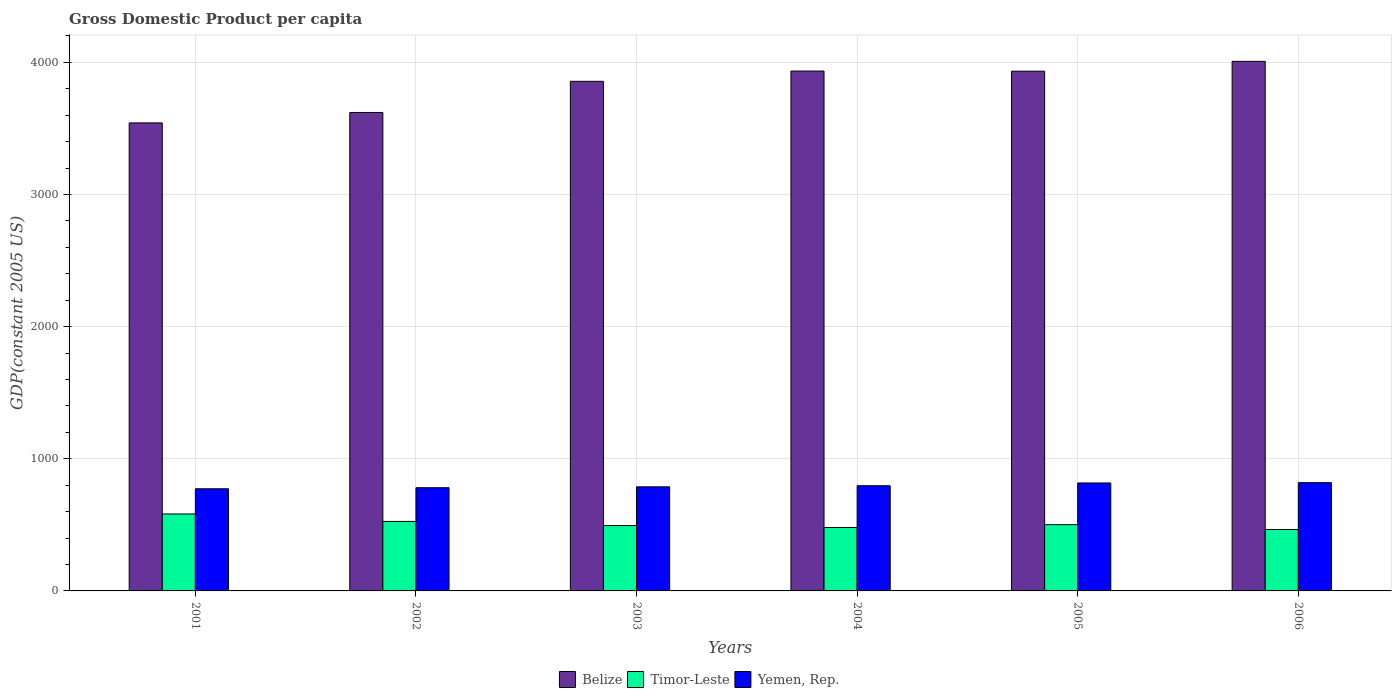Are the number of bars per tick equal to the number of legend labels?
Offer a terse response. Yes. How many bars are there on the 4th tick from the right?
Offer a terse response. 3. In how many cases, is the number of bars for a given year not equal to the number of legend labels?
Your response must be concise. 0. What is the GDP per capita in Timor-Leste in 2002?
Ensure brevity in your answer.  526.06. Across all years, what is the maximum GDP per capita in Belize?
Ensure brevity in your answer.  4007.73. Across all years, what is the minimum GDP per capita in Timor-Leste?
Offer a very short reply. 464.78. What is the total GDP per capita in Belize in the graph?
Your response must be concise. 2.29e+04. What is the difference between the GDP per capita in Yemen, Rep. in 2002 and that in 2004?
Ensure brevity in your answer.  -14.98. What is the difference between the GDP per capita in Timor-Leste in 2003 and the GDP per capita in Belize in 2001?
Your answer should be very brief. -3047.2. What is the average GDP per capita in Yemen, Rep. per year?
Give a very brief answer. 795.73. In the year 2004, what is the difference between the GDP per capita in Timor-Leste and GDP per capita in Yemen, Rep.?
Your answer should be compact. -315.95. In how many years, is the GDP per capita in Yemen, Rep. greater than 4000 US$?
Your answer should be compact. 0. What is the ratio of the GDP per capita in Belize in 2003 to that in 2006?
Keep it short and to the point. 0.96. What is the difference between the highest and the second highest GDP per capita in Belize?
Your response must be concise. 73.43. What is the difference between the highest and the lowest GDP per capita in Timor-Leste?
Your answer should be compact. 117.6. Is the sum of the GDP per capita in Timor-Leste in 2005 and 2006 greater than the maximum GDP per capita in Belize across all years?
Provide a short and direct response. No. What does the 1st bar from the left in 2004 represents?
Your response must be concise. Belize. What does the 3rd bar from the right in 2005 represents?
Your answer should be compact. Belize. Is it the case that in every year, the sum of the GDP per capita in Belize and GDP per capita in Yemen, Rep. is greater than the GDP per capita in Timor-Leste?
Provide a succinct answer. Yes. Are all the bars in the graph horizontal?
Your response must be concise. No. Does the graph contain any zero values?
Make the answer very short. No. Does the graph contain grids?
Your answer should be compact. Yes. Where does the legend appear in the graph?
Give a very brief answer. Bottom center. What is the title of the graph?
Provide a short and direct response. Gross Domestic Product per capita. Does "Panama" appear as one of the legend labels in the graph?
Keep it short and to the point. No. What is the label or title of the X-axis?
Your response must be concise. Years. What is the label or title of the Y-axis?
Keep it short and to the point. GDP(constant 2005 US). What is the GDP(constant 2005 US) in Belize in 2001?
Your response must be concise. 3541.94. What is the GDP(constant 2005 US) in Timor-Leste in 2001?
Offer a very short reply. 582.38. What is the GDP(constant 2005 US) of Yemen, Rep. in 2001?
Your answer should be compact. 773.08. What is the GDP(constant 2005 US) in Belize in 2002?
Provide a short and direct response. 3620.81. What is the GDP(constant 2005 US) in Timor-Leste in 2002?
Your answer should be very brief. 526.06. What is the GDP(constant 2005 US) of Yemen, Rep. in 2002?
Ensure brevity in your answer.  781.07. What is the GDP(constant 2005 US) in Belize in 2003?
Your response must be concise. 3856.68. What is the GDP(constant 2005 US) in Timor-Leste in 2003?
Your response must be concise. 494.74. What is the GDP(constant 2005 US) of Yemen, Rep. in 2003?
Your answer should be very brief. 787.67. What is the GDP(constant 2005 US) in Belize in 2004?
Make the answer very short. 3934.3. What is the GDP(constant 2005 US) of Timor-Leste in 2004?
Your answer should be compact. 480.1. What is the GDP(constant 2005 US) in Yemen, Rep. in 2004?
Offer a very short reply. 796.05. What is the GDP(constant 2005 US) of Belize in 2005?
Provide a succinct answer. 3933.23. What is the GDP(constant 2005 US) in Timor-Leste in 2005?
Provide a short and direct response. 501.43. What is the GDP(constant 2005 US) in Yemen, Rep. in 2005?
Keep it short and to the point. 817.08. What is the GDP(constant 2005 US) in Belize in 2006?
Ensure brevity in your answer.  4007.73. What is the GDP(constant 2005 US) in Timor-Leste in 2006?
Provide a succinct answer. 464.78. What is the GDP(constant 2005 US) of Yemen, Rep. in 2006?
Your answer should be compact. 819.43. Across all years, what is the maximum GDP(constant 2005 US) in Belize?
Make the answer very short. 4007.73. Across all years, what is the maximum GDP(constant 2005 US) in Timor-Leste?
Keep it short and to the point. 582.38. Across all years, what is the maximum GDP(constant 2005 US) of Yemen, Rep.?
Offer a very short reply. 819.43. Across all years, what is the minimum GDP(constant 2005 US) of Belize?
Your response must be concise. 3541.94. Across all years, what is the minimum GDP(constant 2005 US) of Timor-Leste?
Your answer should be compact. 464.78. Across all years, what is the minimum GDP(constant 2005 US) of Yemen, Rep.?
Provide a short and direct response. 773.08. What is the total GDP(constant 2005 US) of Belize in the graph?
Your answer should be compact. 2.29e+04. What is the total GDP(constant 2005 US) in Timor-Leste in the graph?
Offer a very short reply. 3049.48. What is the total GDP(constant 2005 US) of Yemen, Rep. in the graph?
Make the answer very short. 4774.37. What is the difference between the GDP(constant 2005 US) of Belize in 2001 and that in 2002?
Make the answer very short. -78.87. What is the difference between the GDP(constant 2005 US) in Timor-Leste in 2001 and that in 2002?
Make the answer very short. 56.32. What is the difference between the GDP(constant 2005 US) of Yemen, Rep. in 2001 and that in 2002?
Provide a short and direct response. -7.99. What is the difference between the GDP(constant 2005 US) of Belize in 2001 and that in 2003?
Ensure brevity in your answer.  -314.74. What is the difference between the GDP(constant 2005 US) in Timor-Leste in 2001 and that in 2003?
Offer a terse response. 87.64. What is the difference between the GDP(constant 2005 US) of Yemen, Rep. in 2001 and that in 2003?
Keep it short and to the point. -14.59. What is the difference between the GDP(constant 2005 US) in Belize in 2001 and that in 2004?
Make the answer very short. -392.36. What is the difference between the GDP(constant 2005 US) of Timor-Leste in 2001 and that in 2004?
Ensure brevity in your answer.  102.27. What is the difference between the GDP(constant 2005 US) of Yemen, Rep. in 2001 and that in 2004?
Your response must be concise. -22.97. What is the difference between the GDP(constant 2005 US) in Belize in 2001 and that in 2005?
Keep it short and to the point. -391.29. What is the difference between the GDP(constant 2005 US) of Timor-Leste in 2001 and that in 2005?
Your response must be concise. 80.95. What is the difference between the GDP(constant 2005 US) of Yemen, Rep. in 2001 and that in 2005?
Ensure brevity in your answer.  -44. What is the difference between the GDP(constant 2005 US) of Belize in 2001 and that in 2006?
Your response must be concise. -465.79. What is the difference between the GDP(constant 2005 US) in Timor-Leste in 2001 and that in 2006?
Make the answer very short. 117.6. What is the difference between the GDP(constant 2005 US) in Yemen, Rep. in 2001 and that in 2006?
Offer a very short reply. -46.35. What is the difference between the GDP(constant 2005 US) of Belize in 2002 and that in 2003?
Your answer should be very brief. -235.86. What is the difference between the GDP(constant 2005 US) of Timor-Leste in 2002 and that in 2003?
Provide a succinct answer. 31.32. What is the difference between the GDP(constant 2005 US) of Yemen, Rep. in 2002 and that in 2003?
Your answer should be very brief. -6.6. What is the difference between the GDP(constant 2005 US) in Belize in 2002 and that in 2004?
Provide a succinct answer. -313.48. What is the difference between the GDP(constant 2005 US) in Timor-Leste in 2002 and that in 2004?
Keep it short and to the point. 45.96. What is the difference between the GDP(constant 2005 US) in Yemen, Rep. in 2002 and that in 2004?
Provide a short and direct response. -14.98. What is the difference between the GDP(constant 2005 US) of Belize in 2002 and that in 2005?
Your answer should be very brief. -312.42. What is the difference between the GDP(constant 2005 US) of Timor-Leste in 2002 and that in 2005?
Offer a terse response. 24.63. What is the difference between the GDP(constant 2005 US) in Yemen, Rep. in 2002 and that in 2005?
Offer a very short reply. -36.02. What is the difference between the GDP(constant 2005 US) of Belize in 2002 and that in 2006?
Offer a terse response. -386.91. What is the difference between the GDP(constant 2005 US) in Timor-Leste in 2002 and that in 2006?
Offer a terse response. 61.28. What is the difference between the GDP(constant 2005 US) in Yemen, Rep. in 2002 and that in 2006?
Keep it short and to the point. -38.36. What is the difference between the GDP(constant 2005 US) in Belize in 2003 and that in 2004?
Offer a very short reply. -77.62. What is the difference between the GDP(constant 2005 US) of Timor-Leste in 2003 and that in 2004?
Your response must be concise. 14.64. What is the difference between the GDP(constant 2005 US) of Yemen, Rep. in 2003 and that in 2004?
Provide a succinct answer. -8.38. What is the difference between the GDP(constant 2005 US) in Belize in 2003 and that in 2005?
Provide a succinct answer. -76.56. What is the difference between the GDP(constant 2005 US) in Timor-Leste in 2003 and that in 2005?
Keep it short and to the point. -6.69. What is the difference between the GDP(constant 2005 US) in Yemen, Rep. in 2003 and that in 2005?
Keep it short and to the point. -29.41. What is the difference between the GDP(constant 2005 US) in Belize in 2003 and that in 2006?
Offer a terse response. -151.05. What is the difference between the GDP(constant 2005 US) in Timor-Leste in 2003 and that in 2006?
Provide a short and direct response. 29.96. What is the difference between the GDP(constant 2005 US) in Yemen, Rep. in 2003 and that in 2006?
Provide a succinct answer. -31.76. What is the difference between the GDP(constant 2005 US) in Belize in 2004 and that in 2005?
Provide a succinct answer. 1.06. What is the difference between the GDP(constant 2005 US) in Timor-Leste in 2004 and that in 2005?
Ensure brevity in your answer.  -21.33. What is the difference between the GDP(constant 2005 US) of Yemen, Rep. in 2004 and that in 2005?
Provide a succinct answer. -21.03. What is the difference between the GDP(constant 2005 US) of Belize in 2004 and that in 2006?
Offer a very short reply. -73.43. What is the difference between the GDP(constant 2005 US) in Timor-Leste in 2004 and that in 2006?
Your response must be concise. 15.33. What is the difference between the GDP(constant 2005 US) of Yemen, Rep. in 2004 and that in 2006?
Ensure brevity in your answer.  -23.38. What is the difference between the GDP(constant 2005 US) in Belize in 2005 and that in 2006?
Ensure brevity in your answer.  -74.49. What is the difference between the GDP(constant 2005 US) in Timor-Leste in 2005 and that in 2006?
Provide a short and direct response. 36.65. What is the difference between the GDP(constant 2005 US) in Yemen, Rep. in 2005 and that in 2006?
Offer a terse response. -2.34. What is the difference between the GDP(constant 2005 US) in Belize in 2001 and the GDP(constant 2005 US) in Timor-Leste in 2002?
Ensure brevity in your answer.  3015.88. What is the difference between the GDP(constant 2005 US) in Belize in 2001 and the GDP(constant 2005 US) in Yemen, Rep. in 2002?
Provide a short and direct response. 2760.88. What is the difference between the GDP(constant 2005 US) of Timor-Leste in 2001 and the GDP(constant 2005 US) of Yemen, Rep. in 2002?
Offer a terse response. -198.69. What is the difference between the GDP(constant 2005 US) in Belize in 2001 and the GDP(constant 2005 US) in Timor-Leste in 2003?
Keep it short and to the point. 3047.2. What is the difference between the GDP(constant 2005 US) in Belize in 2001 and the GDP(constant 2005 US) in Yemen, Rep. in 2003?
Offer a terse response. 2754.27. What is the difference between the GDP(constant 2005 US) of Timor-Leste in 2001 and the GDP(constant 2005 US) of Yemen, Rep. in 2003?
Offer a very short reply. -205.29. What is the difference between the GDP(constant 2005 US) of Belize in 2001 and the GDP(constant 2005 US) of Timor-Leste in 2004?
Offer a very short reply. 3061.84. What is the difference between the GDP(constant 2005 US) of Belize in 2001 and the GDP(constant 2005 US) of Yemen, Rep. in 2004?
Your answer should be compact. 2745.89. What is the difference between the GDP(constant 2005 US) in Timor-Leste in 2001 and the GDP(constant 2005 US) in Yemen, Rep. in 2004?
Your answer should be very brief. -213.67. What is the difference between the GDP(constant 2005 US) of Belize in 2001 and the GDP(constant 2005 US) of Timor-Leste in 2005?
Offer a terse response. 3040.51. What is the difference between the GDP(constant 2005 US) in Belize in 2001 and the GDP(constant 2005 US) in Yemen, Rep. in 2005?
Keep it short and to the point. 2724.86. What is the difference between the GDP(constant 2005 US) in Timor-Leste in 2001 and the GDP(constant 2005 US) in Yemen, Rep. in 2005?
Offer a terse response. -234.71. What is the difference between the GDP(constant 2005 US) in Belize in 2001 and the GDP(constant 2005 US) in Timor-Leste in 2006?
Make the answer very short. 3077.16. What is the difference between the GDP(constant 2005 US) of Belize in 2001 and the GDP(constant 2005 US) of Yemen, Rep. in 2006?
Offer a terse response. 2722.52. What is the difference between the GDP(constant 2005 US) in Timor-Leste in 2001 and the GDP(constant 2005 US) in Yemen, Rep. in 2006?
Your response must be concise. -237.05. What is the difference between the GDP(constant 2005 US) of Belize in 2002 and the GDP(constant 2005 US) of Timor-Leste in 2003?
Your answer should be very brief. 3126.08. What is the difference between the GDP(constant 2005 US) in Belize in 2002 and the GDP(constant 2005 US) in Yemen, Rep. in 2003?
Offer a very short reply. 2833.15. What is the difference between the GDP(constant 2005 US) of Timor-Leste in 2002 and the GDP(constant 2005 US) of Yemen, Rep. in 2003?
Provide a short and direct response. -261.61. What is the difference between the GDP(constant 2005 US) of Belize in 2002 and the GDP(constant 2005 US) of Timor-Leste in 2004?
Provide a succinct answer. 3140.71. What is the difference between the GDP(constant 2005 US) in Belize in 2002 and the GDP(constant 2005 US) in Yemen, Rep. in 2004?
Your answer should be very brief. 2824.76. What is the difference between the GDP(constant 2005 US) in Timor-Leste in 2002 and the GDP(constant 2005 US) in Yemen, Rep. in 2004?
Ensure brevity in your answer.  -269.99. What is the difference between the GDP(constant 2005 US) in Belize in 2002 and the GDP(constant 2005 US) in Timor-Leste in 2005?
Offer a very short reply. 3119.39. What is the difference between the GDP(constant 2005 US) of Belize in 2002 and the GDP(constant 2005 US) of Yemen, Rep. in 2005?
Offer a very short reply. 2803.73. What is the difference between the GDP(constant 2005 US) in Timor-Leste in 2002 and the GDP(constant 2005 US) in Yemen, Rep. in 2005?
Keep it short and to the point. -291.02. What is the difference between the GDP(constant 2005 US) in Belize in 2002 and the GDP(constant 2005 US) in Timor-Leste in 2006?
Your answer should be very brief. 3156.04. What is the difference between the GDP(constant 2005 US) of Belize in 2002 and the GDP(constant 2005 US) of Yemen, Rep. in 2006?
Your response must be concise. 2801.39. What is the difference between the GDP(constant 2005 US) of Timor-Leste in 2002 and the GDP(constant 2005 US) of Yemen, Rep. in 2006?
Provide a succinct answer. -293.37. What is the difference between the GDP(constant 2005 US) of Belize in 2003 and the GDP(constant 2005 US) of Timor-Leste in 2004?
Your response must be concise. 3376.57. What is the difference between the GDP(constant 2005 US) in Belize in 2003 and the GDP(constant 2005 US) in Yemen, Rep. in 2004?
Your answer should be very brief. 3060.63. What is the difference between the GDP(constant 2005 US) of Timor-Leste in 2003 and the GDP(constant 2005 US) of Yemen, Rep. in 2004?
Provide a short and direct response. -301.31. What is the difference between the GDP(constant 2005 US) of Belize in 2003 and the GDP(constant 2005 US) of Timor-Leste in 2005?
Your answer should be compact. 3355.25. What is the difference between the GDP(constant 2005 US) in Belize in 2003 and the GDP(constant 2005 US) in Yemen, Rep. in 2005?
Your answer should be compact. 3039.59. What is the difference between the GDP(constant 2005 US) in Timor-Leste in 2003 and the GDP(constant 2005 US) in Yemen, Rep. in 2005?
Your answer should be very brief. -322.34. What is the difference between the GDP(constant 2005 US) in Belize in 2003 and the GDP(constant 2005 US) in Timor-Leste in 2006?
Your response must be concise. 3391.9. What is the difference between the GDP(constant 2005 US) in Belize in 2003 and the GDP(constant 2005 US) in Yemen, Rep. in 2006?
Offer a terse response. 3037.25. What is the difference between the GDP(constant 2005 US) of Timor-Leste in 2003 and the GDP(constant 2005 US) of Yemen, Rep. in 2006?
Offer a terse response. -324.69. What is the difference between the GDP(constant 2005 US) in Belize in 2004 and the GDP(constant 2005 US) in Timor-Leste in 2005?
Keep it short and to the point. 3432.87. What is the difference between the GDP(constant 2005 US) in Belize in 2004 and the GDP(constant 2005 US) in Yemen, Rep. in 2005?
Your answer should be very brief. 3117.21. What is the difference between the GDP(constant 2005 US) in Timor-Leste in 2004 and the GDP(constant 2005 US) in Yemen, Rep. in 2005?
Your answer should be very brief. -336.98. What is the difference between the GDP(constant 2005 US) of Belize in 2004 and the GDP(constant 2005 US) of Timor-Leste in 2006?
Ensure brevity in your answer.  3469.52. What is the difference between the GDP(constant 2005 US) in Belize in 2004 and the GDP(constant 2005 US) in Yemen, Rep. in 2006?
Your answer should be very brief. 3114.87. What is the difference between the GDP(constant 2005 US) of Timor-Leste in 2004 and the GDP(constant 2005 US) of Yemen, Rep. in 2006?
Make the answer very short. -339.32. What is the difference between the GDP(constant 2005 US) of Belize in 2005 and the GDP(constant 2005 US) of Timor-Leste in 2006?
Provide a short and direct response. 3468.46. What is the difference between the GDP(constant 2005 US) of Belize in 2005 and the GDP(constant 2005 US) of Yemen, Rep. in 2006?
Ensure brevity in your answer.  3113.81. What is the difference between the GDP(constant 2005 US) in Timor-Leste in 2005 and the GDP(constant 2005 US) in Yemen, Rep. in 2006?
Provide a succinct answer. -318. What is the average GDP(constant 2005 US) of Belize per year?
Provide a short and direct response. 3815.78. What is the average GDP(constant 2005 US) of Timor-Leste per year?
Your response must be concise. 508.25. What is the average GDP(constant 2005 US) in Yemen, Rep. per year?
Ensure brevity in your answer.  795.73. In the year 2001, what is the difference between the GDP(constant 2005 US) of Belize and GDP(constant 2005 US) of Timor-Leste?
Offer a very short reply. 2959.57. In the year 2001, what is the difference between the GDP(constant 2005 US) in Belize and GDP(constant 2005 US) in Yemen, Rep.?
Your answer should be very brief. 2768.86. In the year 2001, what is the difference between the GDP(constant 2005 US) of Timor-Leste and GDP(constant 2005 US) of Yemen, Rep.?
Offer a very short reply. -190.7. In the year 2002, what is the difference between the GDP(constant 2005 US) in Belize and GDP(constant 2005 US) in Timor-Leste?
Offer a terse response. 3094.76. In the year 2002, what is the difference between the GDP(constant 2005 US) of Belize and GDP(constant 2005 US) of Yemen, Rep.?
Provide a succinct answer. 2839.75. In the year 2002, what is the difference between the GDP(constant 2005 US) in Timor-Leste and GDP(constant 2005 US) in Yemen, Rep.?
Your answer should be very brief. -255.01. In the year 2003, what is the difference between the GDP(constant 2005 US) in Belize and GDP(constant 2005 US) in Timor-Leste?
Give a very brief answer. 3361.94. In the year 2003, what is the difference between the GDP(constant 2005 US) of Belize and GDP(constant 2005 US) of Yemen, Rep.?
Your answer should be compact. 3069.01. In the year 2003, what is the difference between the GDP(constant 2005 US) in Timor-Leste and GDP(constant 2005 US) in Yemen, Rep.?
Ensure brevity in your answer.  -292.93. In the year 2004, what is the difference between the GDP(constant 2005 US) of Belize and GDP(constant 2005 US) of Timor-Leste?
Your response must be concise. 3454.19. In the year 2004, what is the difference between the GDP(constant 2005 US) of Belize and GDP(constant 2005 US) of Yemen, Rep.?
Ensure brevity in your answer.  3138.25. In the year 2004, what is the difference between the GDP(constant 2005 US) of Timor-Leste and GDP(constant 2005 US) of Yemen, Rep.?
Your response must be concise. -315.95. In the year 2005, what is the difference between the GDP(constant 2005 US) of Belize and GDP(constant 2005 US) of Timor-Leste?
Make the answer very short. 3431.81. In the year 2005, what is the difference between the GDP(constant 2005 US) in Belize and GDP(constant 2005 US) in Yemen, Rep.?
Offer a terse response. 3116.15. In the year 2005, what is the difference between the GDP(constant 2005 US) of Timor-Leste and GDP(constant 2005 US) of Yemen, Rep.?
Your response must be concise. -315.65. In the year 2006, what is the difference between the GDP(constant 2005 US) of Belize and GDP(constant 2005 US) of Timor-Leste?
Make the answer very short. 3542.95. In the year 2006, what is the difference between the GDP(constant 2005 US) of Belize and GDP(constant 2005 US) of Yemen, Rep.?
Your answer should be very brief. 3188.3. In the year 2006, what is the difference between the GDP(constant 2005 US) in Timor-Leste and GDP(constant 2005 US) in Yemen, Rep.?
Provide a succinct answer. -354.65. What is the ratio of the GDP(constant 2005 US) of Belize in 2001 to that in 2002?
Keep it short and to the point. 0.98. What is the ratio of the GDP(constant 2005 US) in Timor-Leste in 2001 to that in 2002?
Your answer should be very brief. 1.11. What is the ratio of the GDP(constant 2005 US) in Yemen, Rep. in 2001 to that in 2002?
Give a very brief answer. 0.99. What is the ratio of the GDP(constant 2005 US) in Belize in 2001 to that in 2003?
Ensure brevity in your answer.  0.92. What is the ratio of the GDP(constant 2005 US) of Timor-Leste in 2001 to that in 2003?
Your answer should be very brief. 1.18. What is the ratio of the GDP(constant 2005 US) in Yemen, Rep. in 2001 to that in 2003?
Provide a short and direct response. 0.98. What is the ratio of the GDP(constant 2005 US) in Belize in 2001 to that in 2004?
Give a very brief answer. 0.9. What is the ratio of the GDP(constant 2005 US) of Timor-Leste in 2001 to that in 2004?
Offer a terse response. 1.21. What is the ratio of the GDP(constant 2005 US) of Yemen, Rep. in 2001 to that in 2004?
Your answer should be very brief. 0.97. What is the ratio of the GDP(constant 2005 US) in Belize in 2001 to that in 2005?
Provide a short and direct response. 0.9. What is the ratio of the GDP(constant 2005 US) in Timor-Leste in 2001 to that in 2005?
Your response must be concise. 1.16. What is the ratio of the GDP(constant 2005 US) in Yemen, Rep. in 2001 to that in 2005?
Keep it short and to the point. 0.95. What is the ratio of the GDP(constant 2005 US) of Belize in 2001 to that in 2006?
Offer a terse response. 0.88. What is the ratio of the GDP(constant 2005 US) of Timor-Leste in 2001 to that in 2006?
Your answer should be very brief. 1.25. What is the ratio of the GDP(constant 2005 US) of Yemen, Rep. in 2001 to that in 2006?
Offer a terse response. 0.94. What is the ratio of the GDP(constant 2005 US) in Belize in 2002 to that in 2003?
Provide a short and direct response. 0.94. What is the ratio of the GDP(constant 2005 US) of Timor-Leste in 2002 to that in 2003?
Make the answer very short. 1.06. What is the ratio of the GDP(constant 2005 US) in Belize in 2002 to that in 2004?
Offer a terse response. 0.92. What is the ratio of the GDP(constant 2005 US) in Timor-Leste in 2002 to that in 2004?
Your response must be concise. 1.1. What is the ratio of the GDP(constant 2005 US) of Yemen, Rep. in 2002 to that in 2004?
Offer a very short reply. 0.98. What is the ratio of the GDP(constant 2005 US) in Belize in 2002 to that in 2005?
Your response must be concise. 0.92. What is the ratio of the GDP(constant 2005 US) of Timor-Leste in 2002 to that in 2005?
Offer a terse response. 1.05. What is the ratio of the GDP(constant 2005 US) in Yemen, Rep. in 2002 to that in 2005?
Make the answer very short. 0.96. What is the ratio of the GDP(constant 2005 US) of Belize in 2002 to that in 2006?
Your response must be concise. 0.9. What is the ratio of the GDP(constant 2005 US) of Timor-Leste in 2002 to that in 2006?
Give a very brief answer. 1.13. What is the ratio of the GDP(constant 2005 US) in Yemen, Rep. in 2002 to that in 2006?
Offer a very short reply. 0.95. What is the ratio of the GDP(constant 2005 US) in Belize in 2003 to that in 2004?
Provide a succinct answer. 0.98. What is the ratio of the GDP(constant 2005 US) in Timor-Leste in 2003 to that in 2004?
Your answer should be compact. 1.03. What is the ratio of the GDP(constant 2005 US) of Belize in 2003 to that in 2005?
Keep it short and to the point. 0.98. What is the ratio of the GDP(constant 2005 US) in Timor-Leste in 2003 to that in 2005?
Your answer should be very brief. 0.99. What is the ratio of the GDP(constant 2005 US) in Yemen, Rep. in 2003 to that in 2005?
Make the answer very short. 0.96. What is the ratio of the GDP(constant 2005 US) of Belize in 2003 to that in 2006?
Your answer should be compact. 0.96. What is the ratio of the GDP(constant 2005 US) in Timor-Leste in 2003 to that in 2006?
Offer a terse response. 1.06. What is the ratio of the GDP(constant 2005 US) in Yemen, Rep. in 2003 to that in 2006?
Give a very brief answer. 0.96. What is the ratio of the GDP(constant 2005 US) in Belize in 2004 to that in 2005?
Your answer should be very brief. 1. What is the ratio of the GDP(constant 2005 US) in Timor-Leste in 2004 to that in 2005?
Offer a very short reply. 0.96. What is the ratio of the GDP(constant 2005 US) of Yemen, Rep. in 2004 to that in 2005?
Provide a succinct answer. 0.97. What is the ratio of the GDP(constant 2005 US) of Belize in 2004 to that in 2006?
Give a very brief answer. 0.98. What is the ratio of the GDP(constant 2005 US) in Timor-Leste in 2004 to that in 2006?
Provide a short and direct response. 1.03. What is the ratio of the GDP(constant 2005 US) in Yemen, Rep. in 2004 to that in 2006?
Offer a very short reply. 0.97. What is the ratio of the GDP(constant 2005 US) in Belize in 2005 to that in 2006?
Offer a terse response. 0.98. What is the ratio of the GDP(constant 2005 US) of Timor-Leste in 2005 to that in 2006?
Your answer should be very brief. 1.08. What is the difference between the highest and the second highest GDP(constant 2005 US) of Belize?
Your response must be concise. 73.43. What is the difference between the highest and the second highest GDP(constant 2005 US) of Timor-Leste?
Provide a succinct answer. 56.32. What is the difference between the highest and the second highest GDP(constant 2005 US) in Yemen, Rep.?
Your answer should be compact. 2.34. What is the difference between the highest and the lowest GDP(constant 2005 US) in Belize?
Provide a succinct answer. 465.79. What is the difference between the highest and the lowest GDP(constant 2005 US) of Timor-Leste?
Offer a very short reply. 117.6. What is the difference between the highest and the lowest GDP(constant 2005 US) of Yemen, Rep.?
Keep it short and to the point. 46.35. 